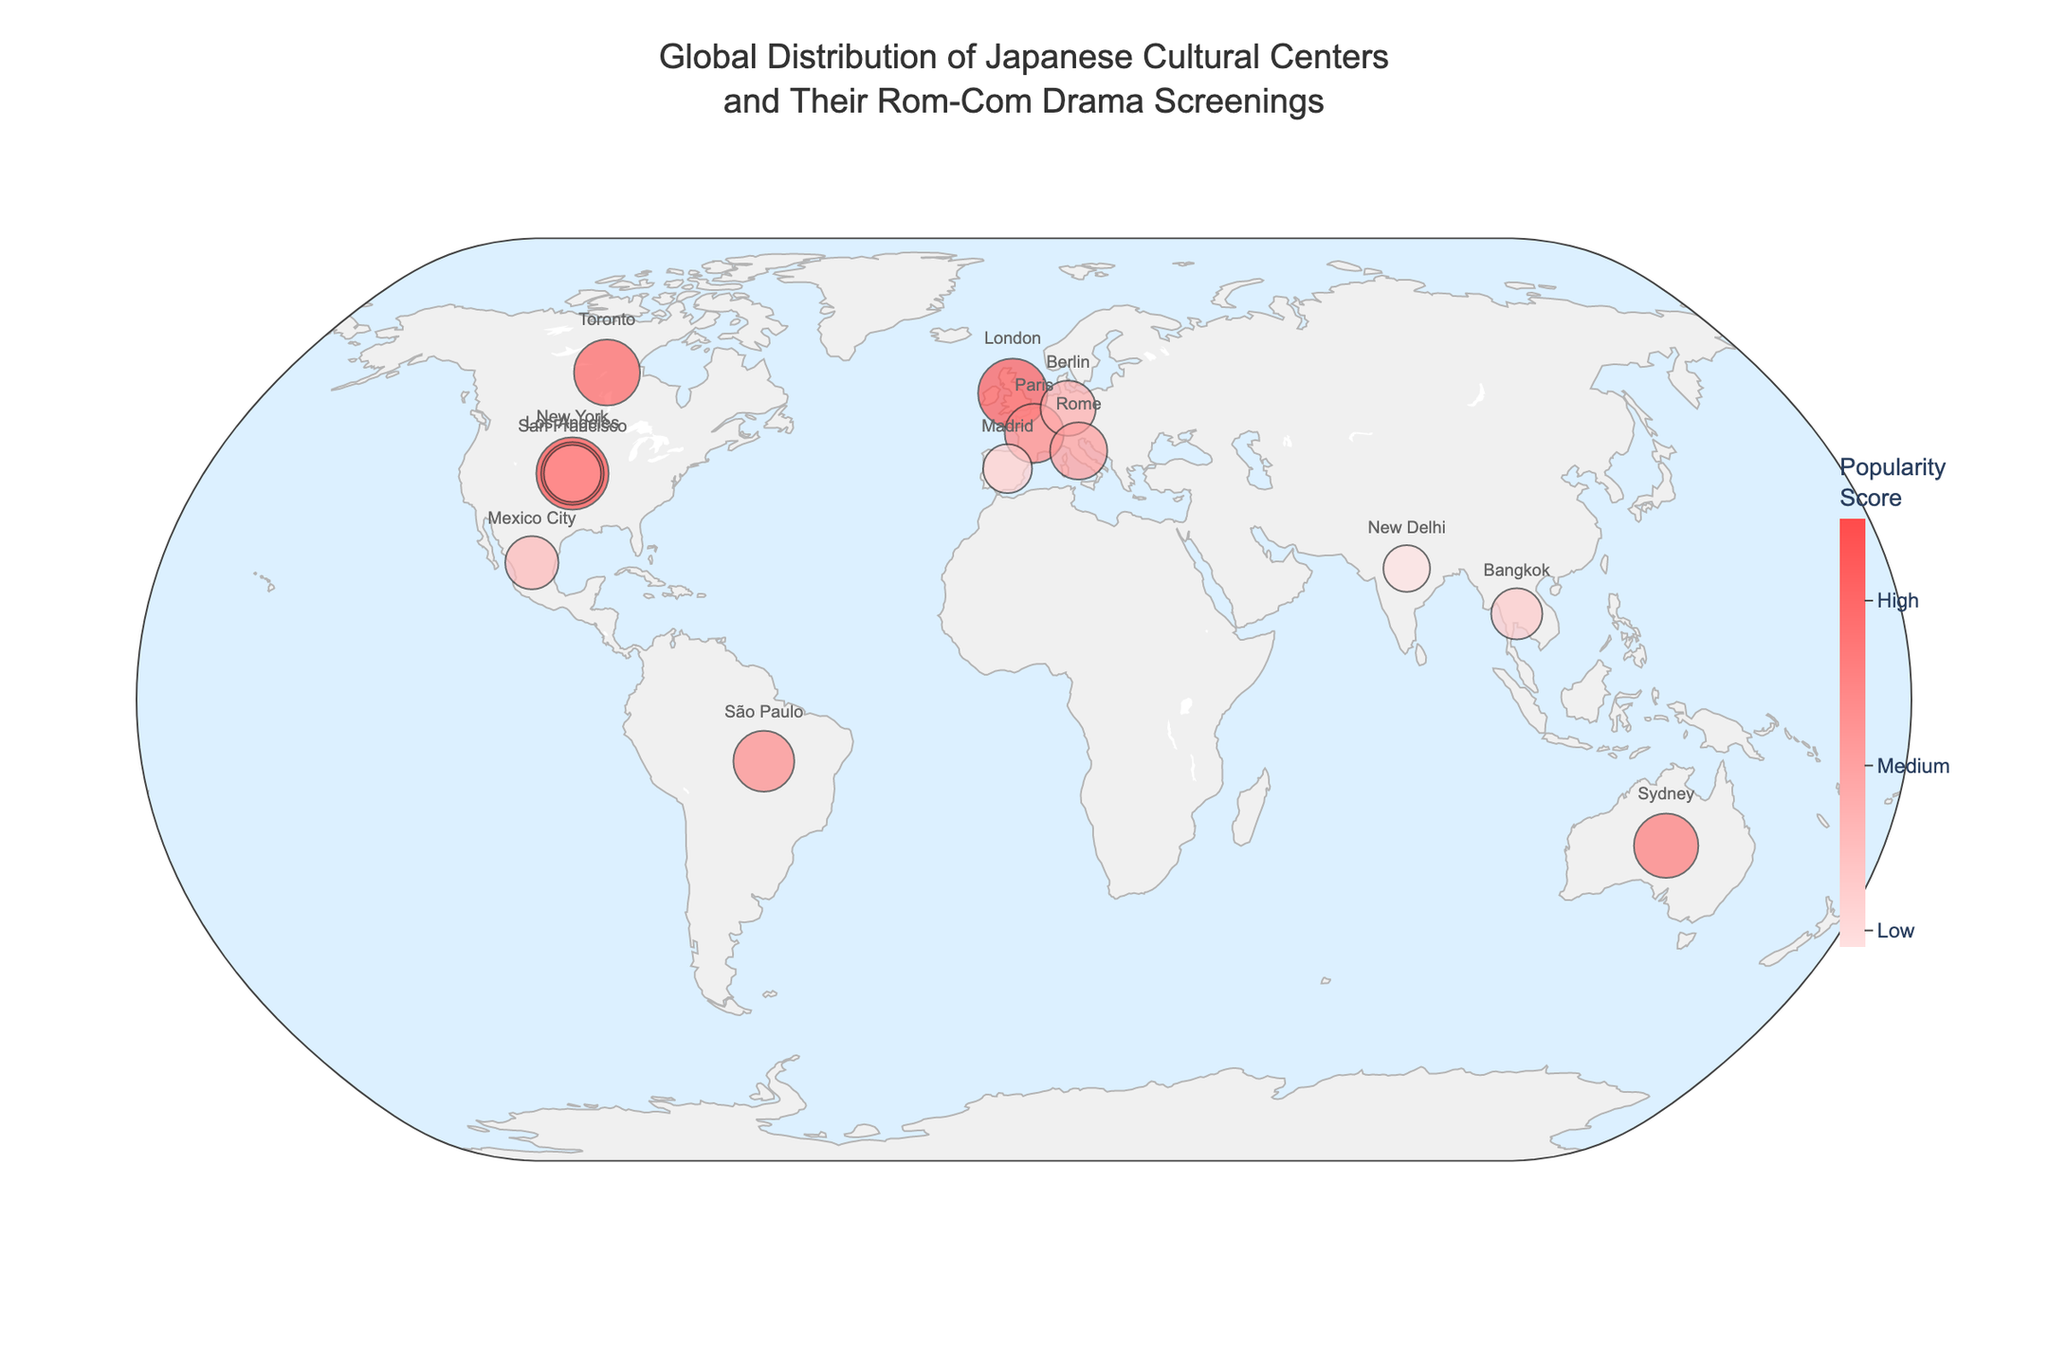Which city has the highest number of annual rom-com screenings? According to the geographic plot, New York City displays the highest number of annual rom-com screenings with 24.
Answer: New York City How many cities host Japanese cultural centers? The geographic plot shows multiple points spread across different continents. Counting the points reveals 14 cities with Japanese cultural centers.
Answer: 14 Which city has the highest popularity score? By examining the color gradient in the plot, New York City is the most prominent, indicating a popularity score of 8.5.
Answer: New York City What is the average number of annual rom-com screenings across all cities? Summing up all the annual rom-com screenings (24 + 18 + 15 + 20 + 22 + 16 + 14 + 19 + 17 + 13 + 21 + 12 + 10 + 15 + 11) gives 247. Dividing by the number of cities (14) results in an average of approximately 17.64.
Answer: 17.64 Which country has the most cities with Japanese cultural centers? From the plot, USA appears with three cities: New York, Los Angeles, and San Francisco, more than any other country.
Answer: USA Compare the popularity scores of cultural centers in New York and Los Angeles. Which one is higher? New York has a popularity score of 8.5 while Los Angeles has a score of 7.9. New York's score is higher.
Answer: New York Which cultural center in Europe organizes the most rom-com drama screenings annually? The European cities in the plot are London, Paris, Berlin, Rome, and Madrid. Among them, London hosts 22 annual screenings, the highest in Europe.
Answer: London How many total annual rom-com screenings are there for cultural centers in North America? The North American cities are New York (24), Los Angeles (18), San Francisco (15), Toronto (20), and Mexico City (13). Summing them up (24 + 18 + 15 + 20 + 13) results in 90 annual screenings.
Answer: 90 What is the combined popularity score for cultural centers in Asia? The Asian cities listed in the plot are Singapore (8.0), Bangkok (6.3), and New Delhi (5.9). Summing up the scores (8.0 + 6.3 + 5.9) results in a combined score of 20.2.
Answer: 20.2 What color represents cultural centers with the highest popularity score on the plot? The color scale in the plot shows the highest popularity centers marked with a deeper red color (approximately "#FF4B4B").
Answer: Deep red 